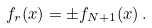<formula> <loc_0><loc_0><loc_500><loc_500>f _ { r } ( x ) = \pm f _ { N + 1 } ( x ) \, .</formula> 